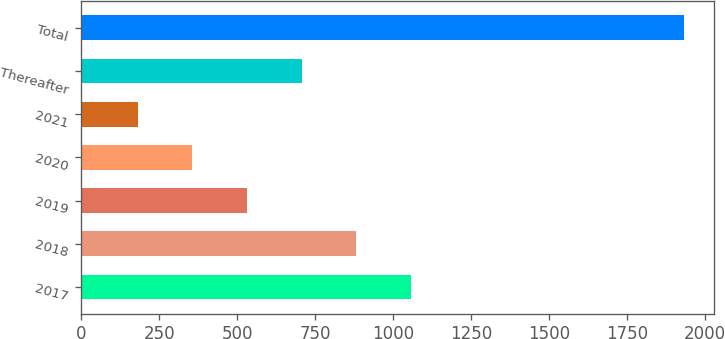Convert chart. <chart><loc_0><loc_0><loc_500><loc_500><bar_chart><fcel>2017<fcel>2018<fcel>2019<fcel>2020<fcel>2021<fcel>Thereafter<fcel>Total<nl><fcel>1057<fcel>882<fcel>532<fcel>357<fcel>182<fcel>707<fcel>1932<nl></chart> 